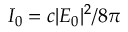Convert formula to latex. <formula><loc_0><loc_0><loc_500><loc_500>I _ { 0 } = c | E _ { 0 } | ^ { 2 } / 8 \pi</formula> 